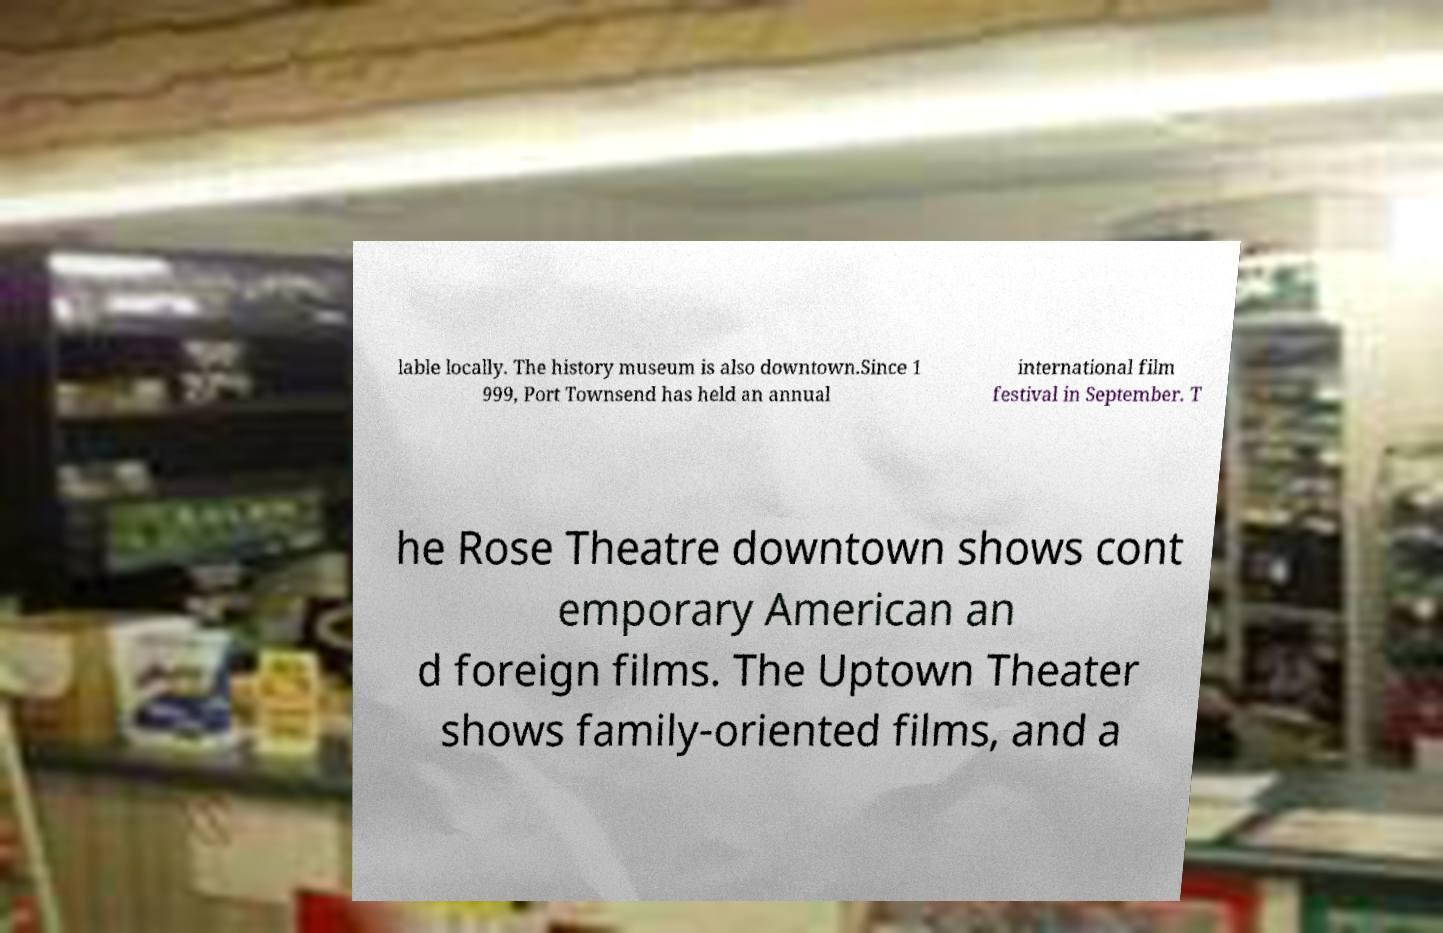Please identify and transcribe the text found in this image. lable locally. The history museum is also downtown.Since 1 999, Port Townsend has held an annual international film festival in September. T he Rose Theatre downtown shows cont emporary American an d foreign films. The Uptown Theater shows family-oriented films, and a 